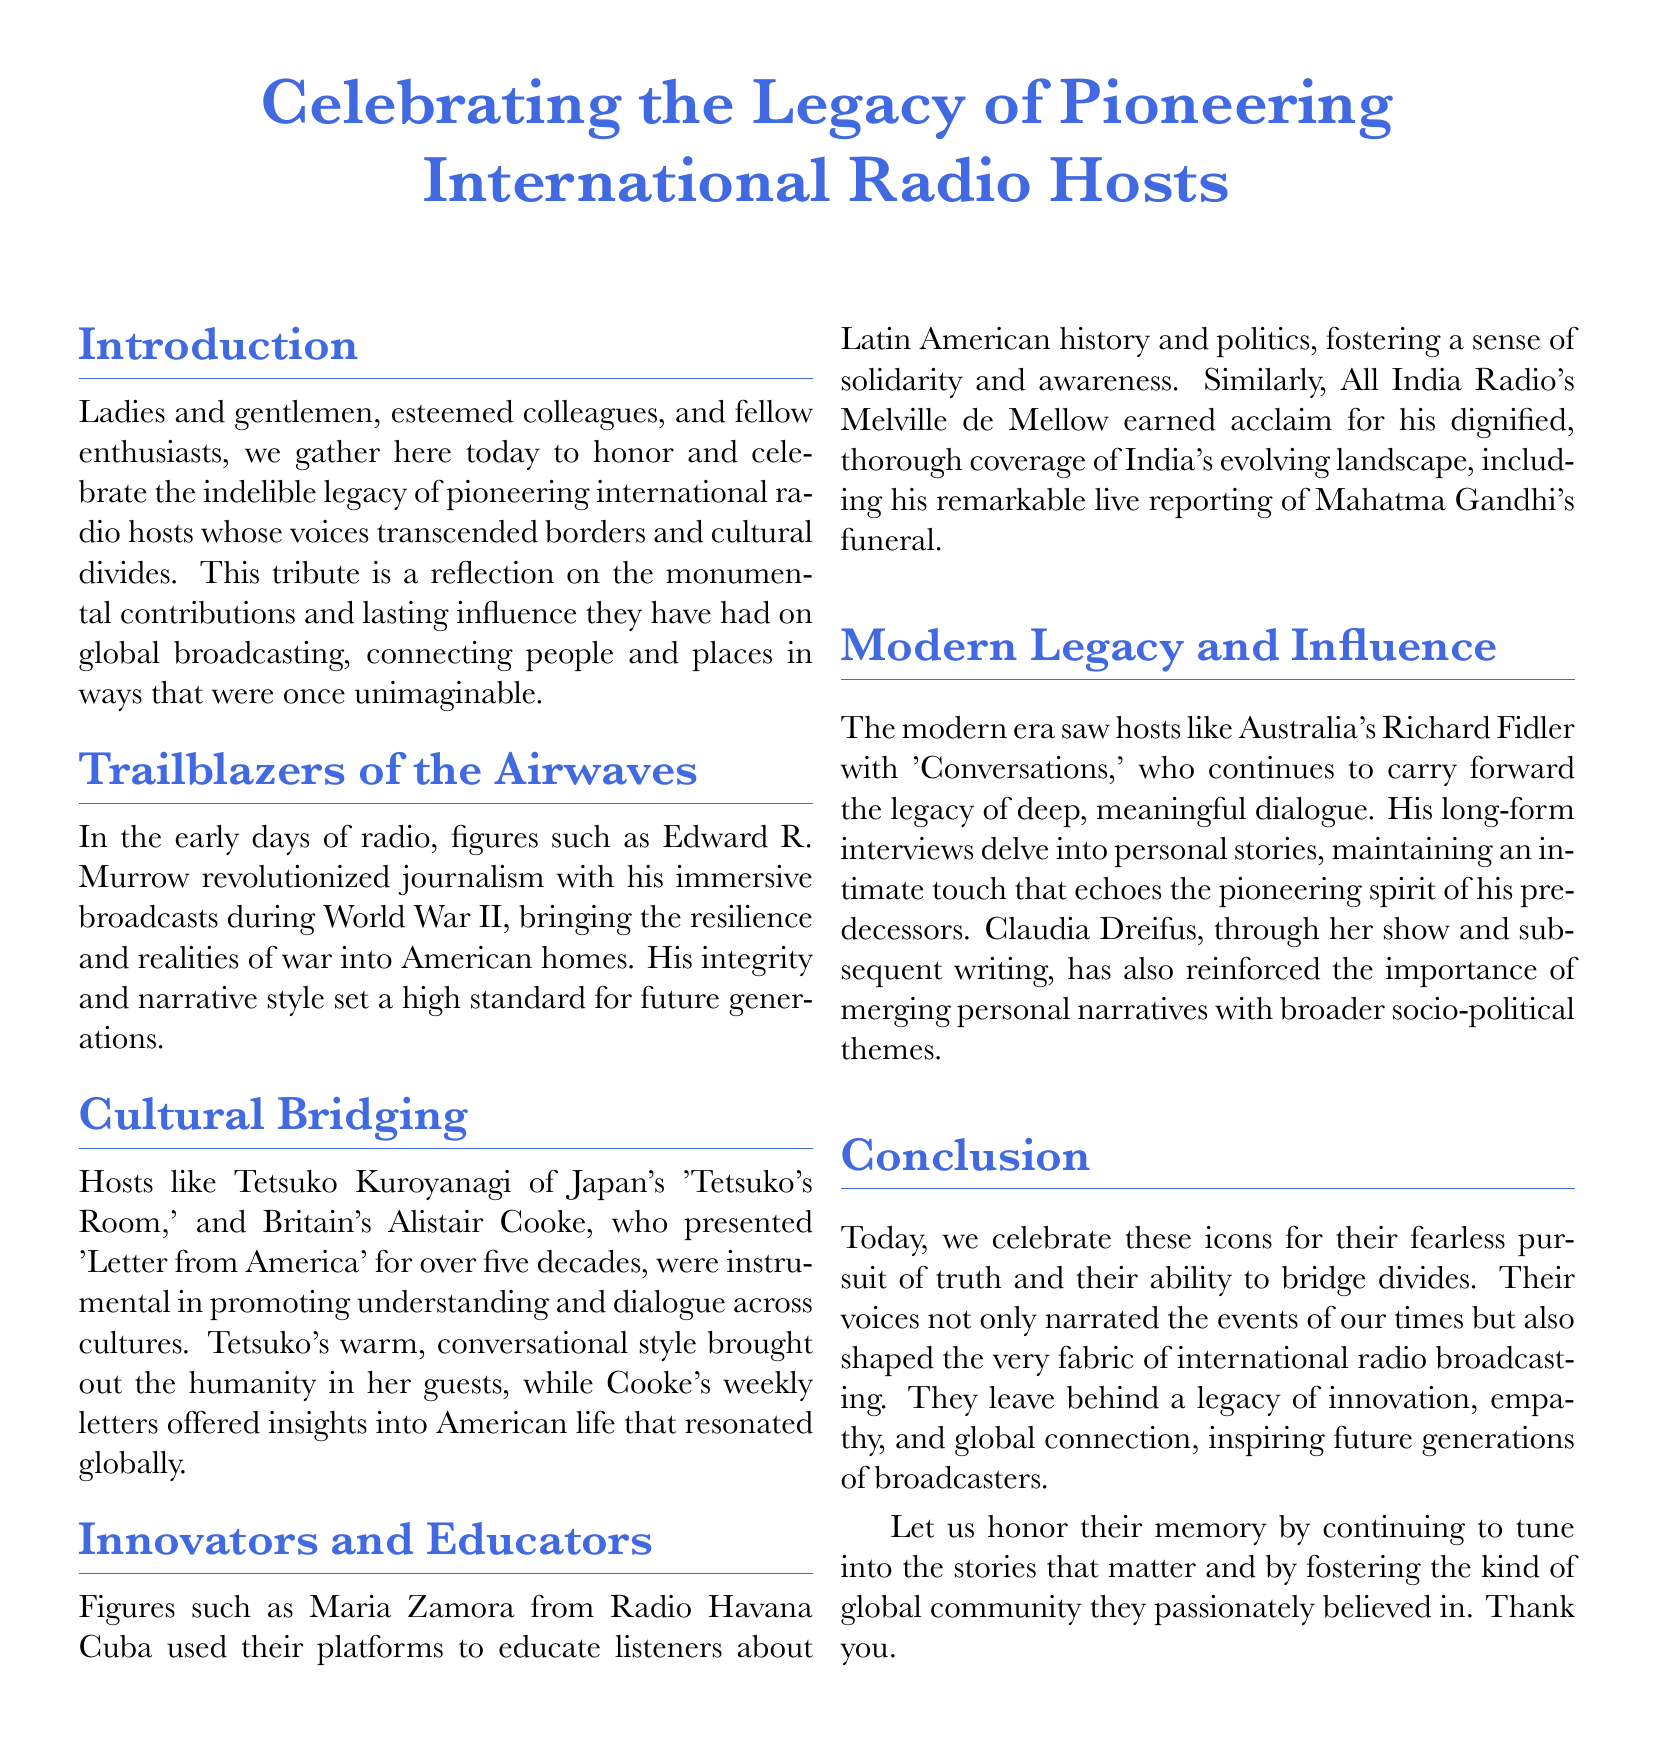What was the title of the tribute? The title is explicitly stated at the beginning of the document and is "Celebrating the Legacy of Pioneering International Radio Hosts."
Answer: Celebrating the Legacy of Pioneering International Radio Hosts Who is mentioned as a trailblazer of the airwaves? Edward R. Murrow is recognized as a pioneering figure for his impactful broadcasts during World War II.
Answer: Edward R. Murrow What show did Alistair Cooke present? The document specifies that Alistair Cooke presented "Letter from America" for over five decades.
Answer: Letter from America Which radio host is known for their warm, conversational style? Tetsuko Kuroyanagi is noted for her warm, conversational approach in her show "Tetsuko's Room."
Answer: Tetsuko's Room What type of legacy do the modern hosts carry forward? The document describes that modern hosts continue the legacy of deep, meaningful dialogue.
Answer: Deep, meaningful dialogue How long did Alistair Cooke present his show? The text indicates that Alistair Cooke presented his show for over five decades.
Answer: Over five decades What was Maria Zamora's contribution to radio? Maria Zamora used her platform to educate listeners about Latin American history and politics.
Answer: Educate listeners about Latin American history and politics What emotion do the pioneering hosts inspire according to the conclusion? The document closes by stating that these hosts inspire a sense of global connection.
Answer: Global connection What was Melville de Mellow known for? Melville de Mellow is recognized for his dignified, thorough coverage of India's evolving landscape.
Answer: Dignified, thorough coverage of India's evolving landscape 